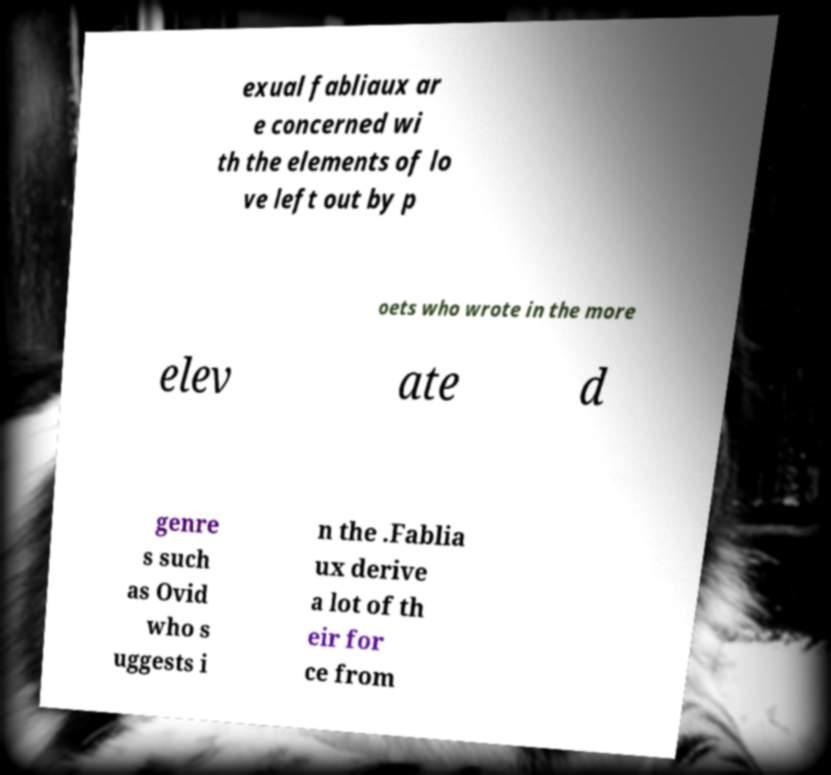Can you accurately transcribe the text from the provided image for me? exual fabliaux ar e concerned wi th the elements of lo ve left out by p oets who wrote in the more elev ate d genre s such as Ovid who s uggests i n the .Fablia ux derive a lot of th eir for ce from 